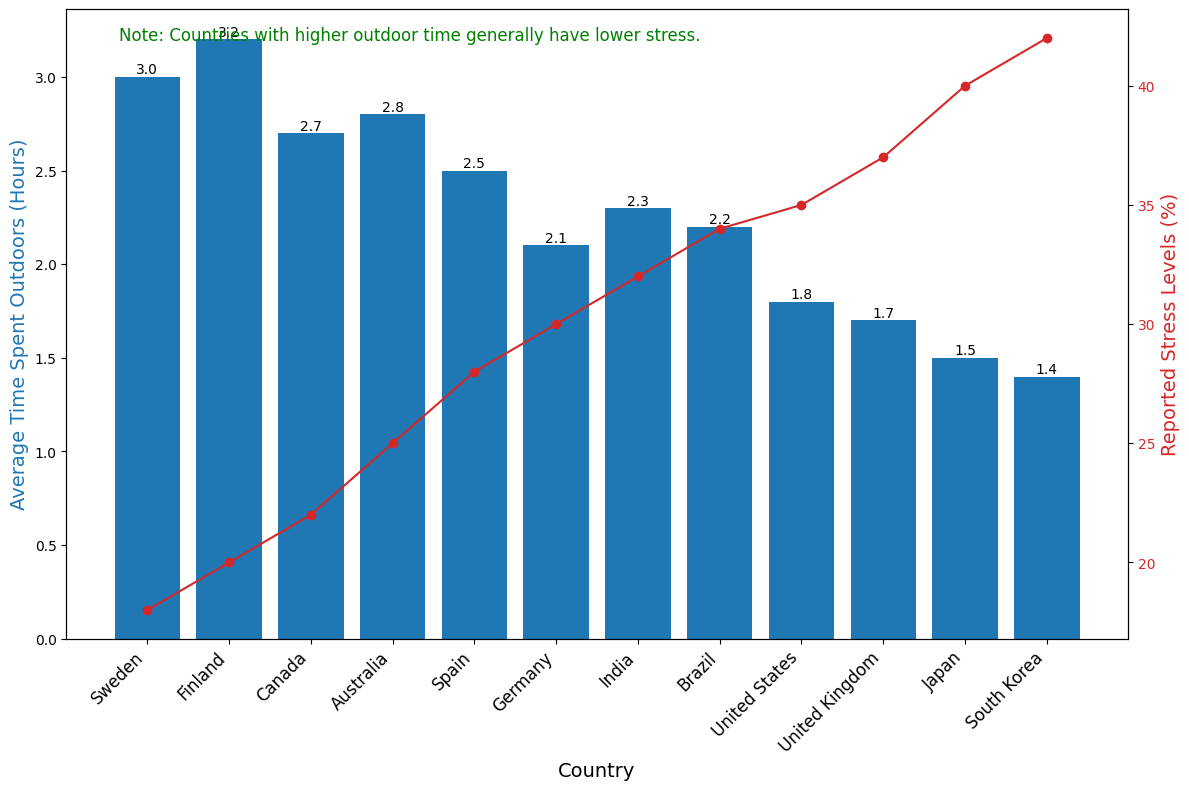Which country reports the lowest stress levels? By looking at the line plot with red markers, identify the point that has the lowest position on the y-axis. Sweden has the lowest reported stress level.
Answer: Sweden Which country spends the most average time outdoors? By examining the heights of the blue bars, identify the tallest one. Finland has the tallest bar, representing the highest average time spent outdoors.
Answer: Finland What is the difference in reported stress levels between South Korea and Sweden? Locate both countries on the line plot. South Korea has a stress level of 42%, and Sweden has 18%. The difference is 42% - 18% = 24%.
Answer: 24% Which countries have a reported stress level greater than 30%? Identify the points on the line plot that are above the 30% stress level mark. These countries are Japan, United States, Germany, Brazil, United Kingdom, India, and South Korea.
Answer: Japan, United States, Germany, Brazil, United Kingdom, India, South Korea What is the combined average time spent outdoors for Finland and Sweden? Sum the average time spent outdoors for Finland (3.2 hours) and Sweden (3.0 hours). The combined total is 3.2 + 3.0 = 6.2 hours.
Answer: 6.2 hours What is the average reported stress level for Japan, Brazil, and United Kingdom? Sum the reported stress levels for these countries (40%, 34%, 37%) and divide by 3. The calculation is (40 + 34 + 37) / 3 = 111 / 3 = 37%.
Answer: 37% Which country has a stress level closest to the median stress level? First, list all the reported stress levels and find the median value, which is the middle value when the data is ordered. The ordered stress levels are 18, 20, 22, 25, 28, 30, 32, 34, 35, 37, 40, 42. There are 12 values, so the median is (30 + 32) / 2 = 31%. India has a stress level of 32%, which is closest to the median.
Answer: India What is the visual relationship between time spent outdoors and reported stress levels, based on the annotation? The annotation directly states the observed trend: countries with higher outdoor time generally have lower stress levels.
Answer: Higher outdoor time, lower stress Which country spends the least amount of time outdoors? By examining the heights of the blue bars, identify the shortest one. South Korea has the shortest bar, indicating the least time spent outdoors.
Answer: South Korea 